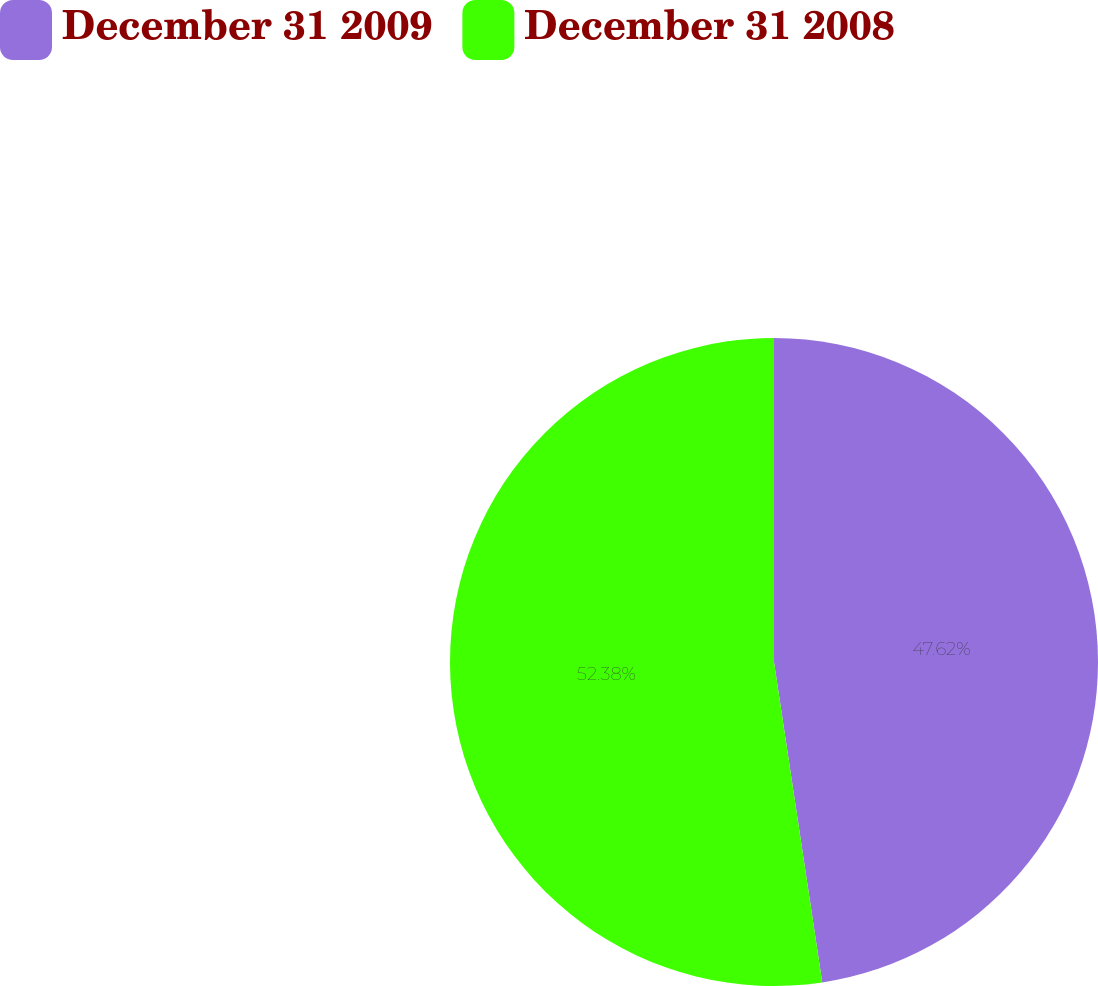<chart> <loc_0><loc_0><loc_500><loc_500><pie_chart><fcel>December 31 2009<fcel>December 31 2008<nl><fcel>47.62%<fcel>52.38%<nl></chart> 